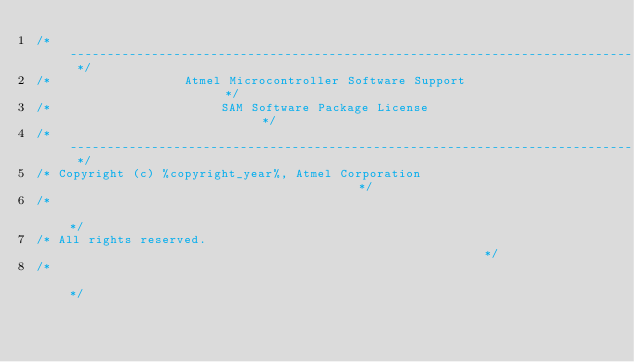<code> <loc_0><loc_0><loc_500><loc_500><_C_>/* ---------------------------------------------------------------------------- */
/*                  Atmel Microcontroller Software Support                      */
/*                       SAM Software Package License                           */
/* ---------------------------------------------------------------------------- */
/* Copyright (c) %copyright_year%, Atmel Corporation                                        */
/*                                                                              */
/* All rights reserved.                                                         */
/*                                                                              */</code> 